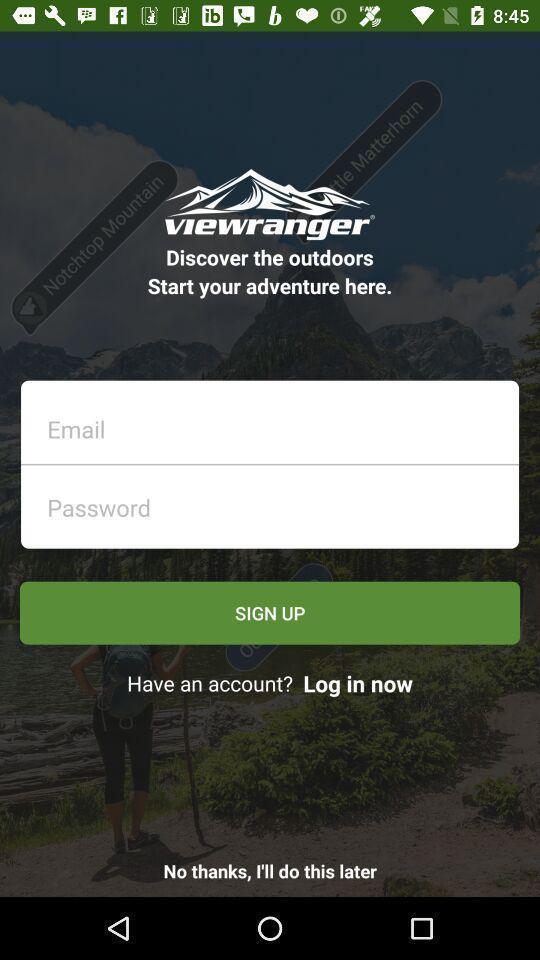Give me a narrative description of this picture. Sign up page. 